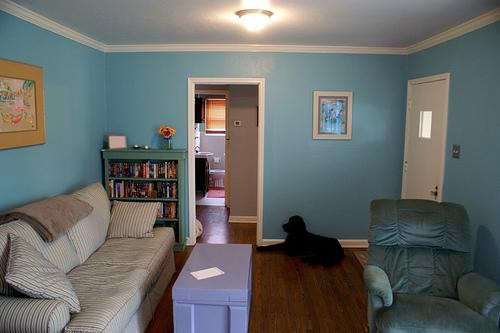Is the dog all alone?
Write a very short answer. Yes. Is the living space too small for the dog?
Quick response, please. No. What color are the walls?
Short answer required. Blue. 